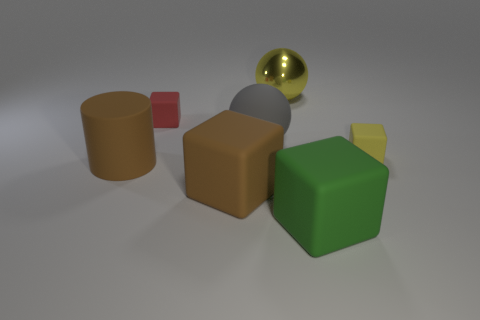There is a object that is the same color as the metal ball; what is it made of?
Ensure brevity in your answer.  Rubber. Are there any big metal cylinders that have the same color as the big metallic object?
Your response must be concise. No. There is a brown block that is the same size as the green matte block; what is its material?
Ensure brevity in your answer.  Rubber. There is a brown object that is to the left of the small matte object behind the small yellow block; what is its material?
Give a very brief answer. Rubber. There is a yellow object that is in front of the large matte ball; does it have the same shape as the large gray object?
Provide a short and direct response. No. There is a ball that is made of the same material as the cylinder; what color is it?
Your answer should be compact. Gray. There is a small cube that is to the right of the brown block; what is it made of?
Give a very brief answer. Rubber. Is the shape of the tiny red matte object the same as the yellow thing on the left side of the yellow rubber object?
Your response must be concise. No. There is a block that is behind the brown cylinder and in front of the big matte ball; what is its material?
Give a very brief answer. Rubber. What color is the other ball that is the same size as the metal sphere?
Give a very brief answer. Gray. 